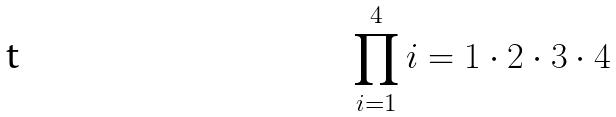Convert formula to latex. <formula><loc_0><loc_0><loc_500><loc_500>\prod _ { i = 1 } ^ { 4 } i = 1 \cdot 2 \cdot 3 \cdot 4</formula> 